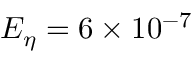<formula> <loc_0><loc_0><loc_500><loc_500>E _ { \eta } = 6 \times 1 0 ^ { - 7 }</formula> 